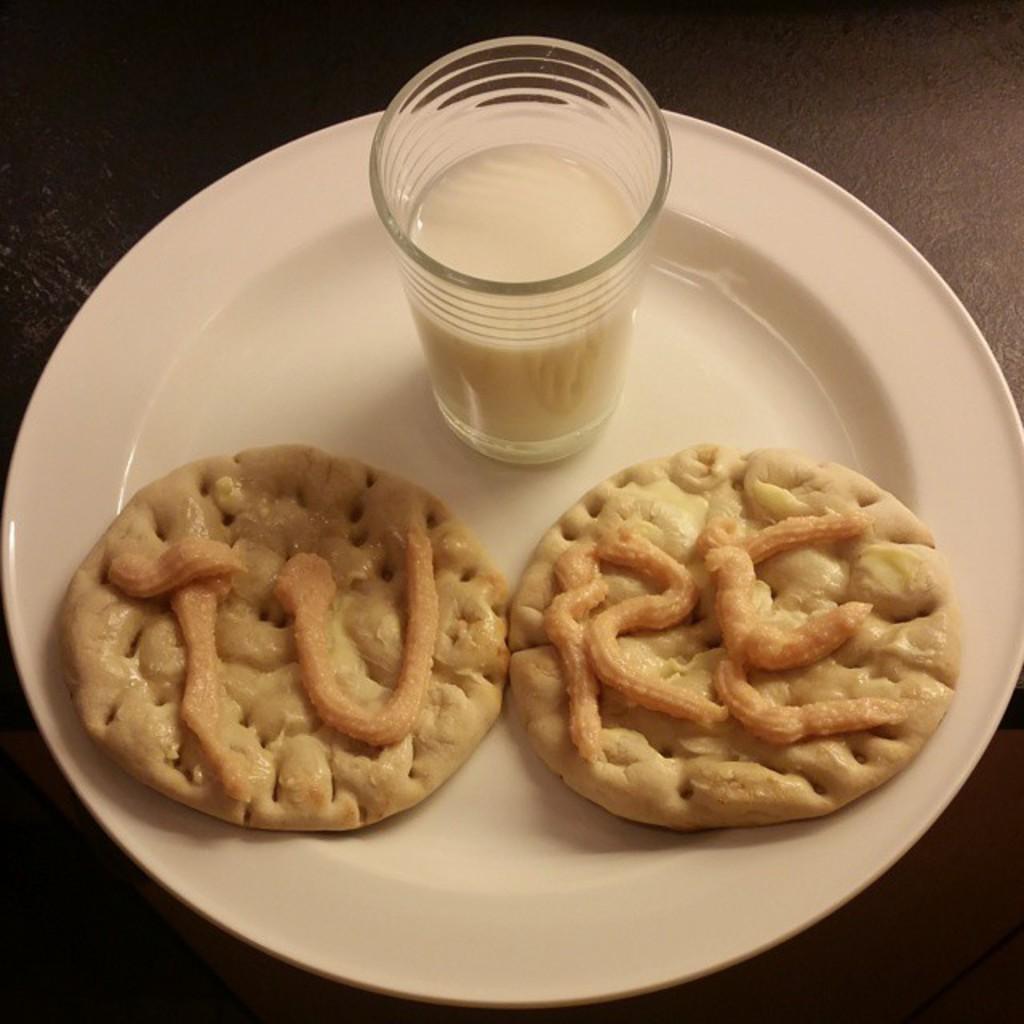Can you describe this image briefly? In this image there is a table. On top of the table there is a plate. On the plate there are two cookies and a glass of milk. 